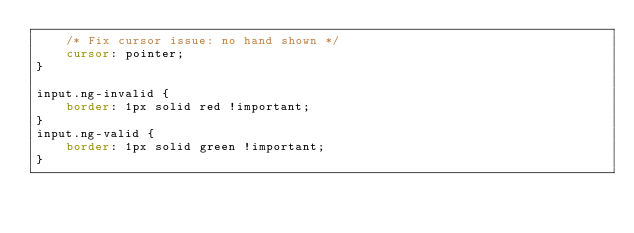Convert code to text. <code><loc_0><loc_0><loc_500><loc_500><_CSS_>	/* Fix cursor issue: no hand shown */
	cursor: pointer;
}

input.ng-invalid {
	border: 1px solid red !important;
}
input.ng-valid {
	border: 1px solid green !important;
}</code> 